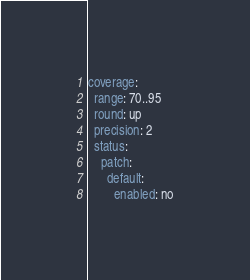Convert code to text. <code><loc_0><loc_0><loc_500><loc_500><_YAML_>coverage:
  range: 70..95
  round: up
  precision: 2
  status:
    patch:
      default:
        enabled: no
</code> 